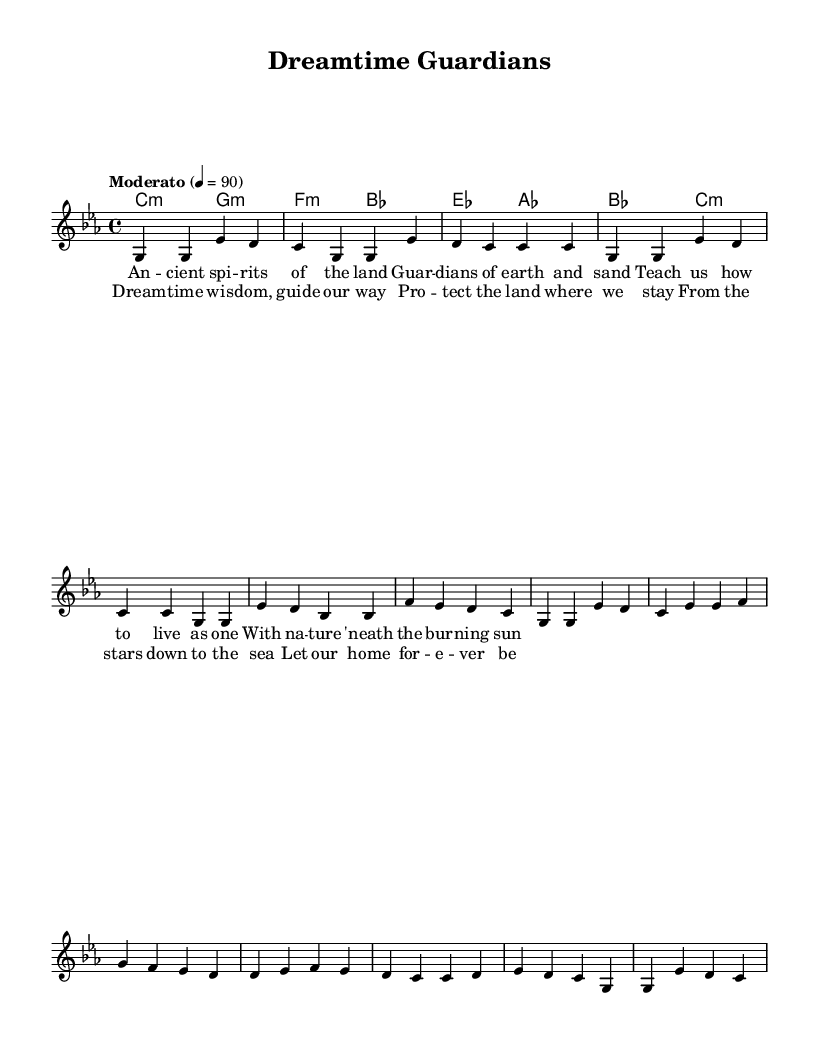What is the key signature of this music? The key signature is C minor, indicated by three flats on the staff.
Answer: C minor What is the time signature of this music? The time signature is 4/4, which is shown at the beginning of the score.
Answer: 4/4 What is the tempo marking of the piece? The tempo marking is "Moderato," with a tempo indication of quarter note equals 90 beats per minute.
Answer: Moderato How many measures are in the verse section? The verse section contains 4 measures, as indicated in the melody and lyrics.
Answer: 4 What is the primary theme of the lyrics? The lyrics emphasize the connection and guardianship of nature, focusing on ancient spirits and wisdom for conservation.
Answer: Nature conservation In the chorus, what do the lyrics suggest about the role of wisdom? The lyrics suggest that wisdom provides guidance for protecting the environment where the community resides.
Answer: Guide our way What are the two main musical elements that together convey the theme of the song? The melody and harmonies combine to create a reflective atmosphere, supporting the theme of nature conservation.
Answer: Melody and harmonies 